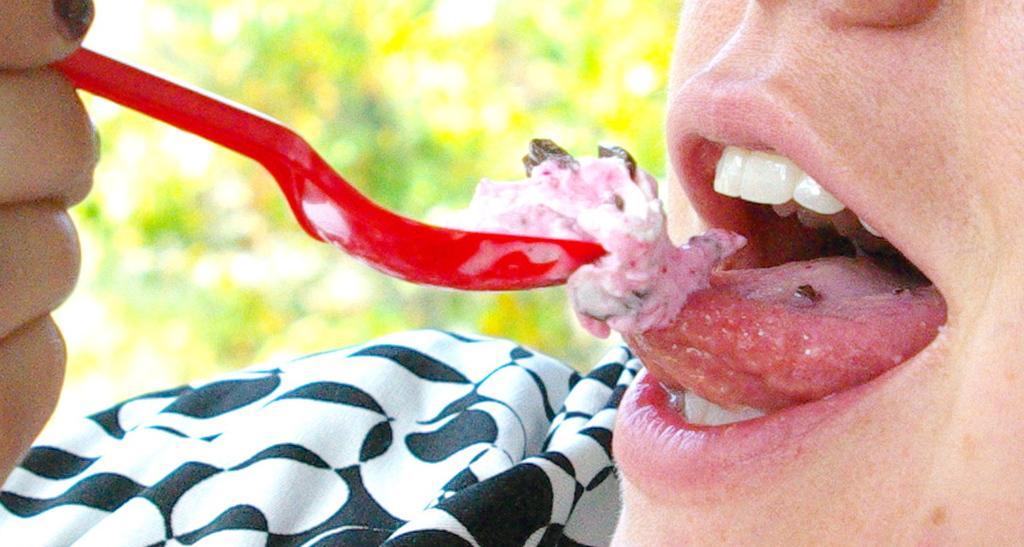Describe this image in one or two sentences. In this image we can see one person is eating ice cream with red color spoon. In the background the image is in a blur. 